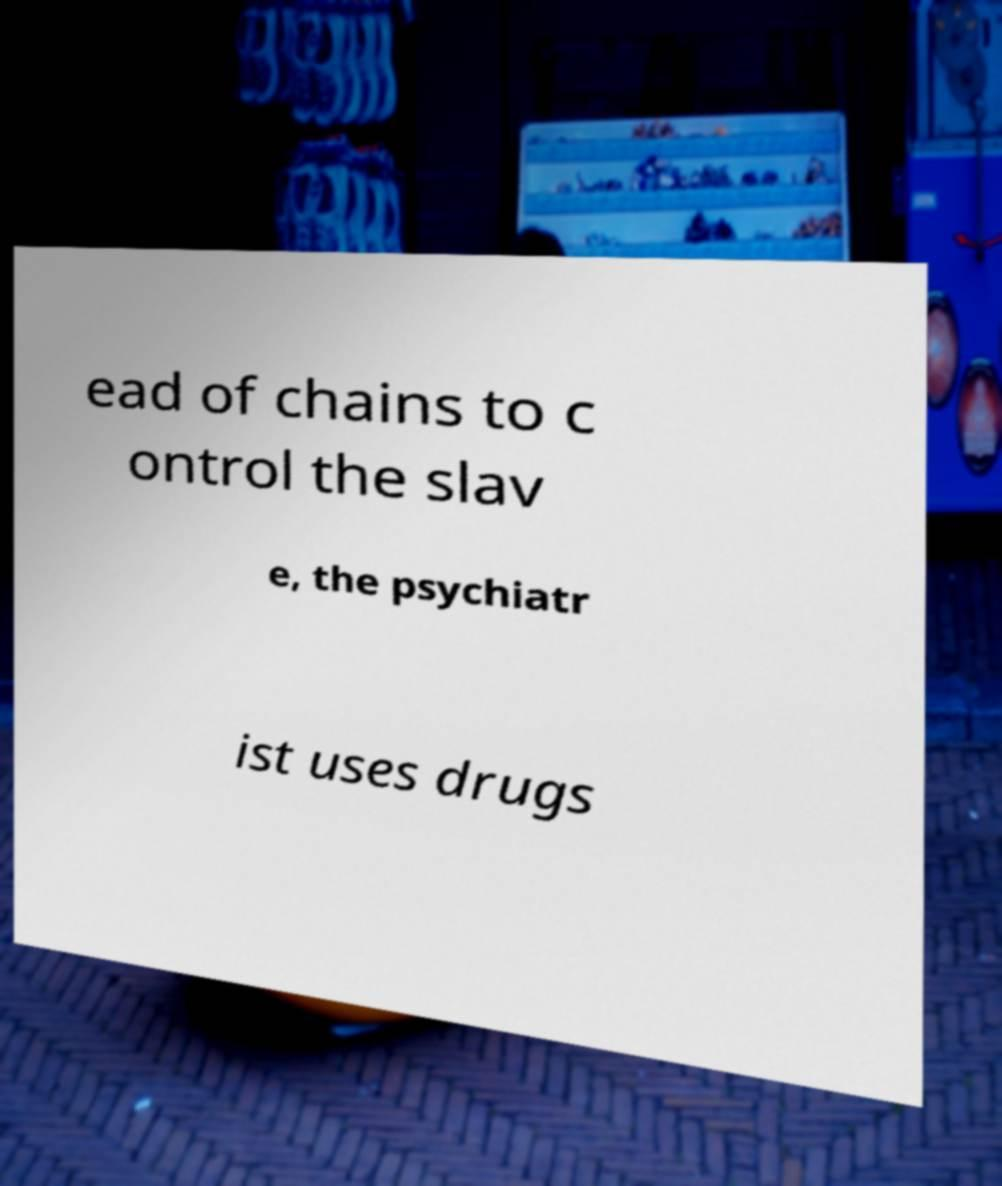I need the written content from this picture converted into text. Can you do that? ead of chains to c ontrol the slav e, the psychiatr ist uses drugs 